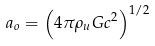Convert formula to latex. <formula><loc_0><loc_0><loc_500><loc_500>a _ { o } = \left ( 4 \pi \rho _ { u } G c ^ { 2 } \right ) ^ { 1 / 2 }</formula> 